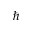<formula> <loc_0><loc_0><loc_500><loc_500>{ \hslash }</formula> 